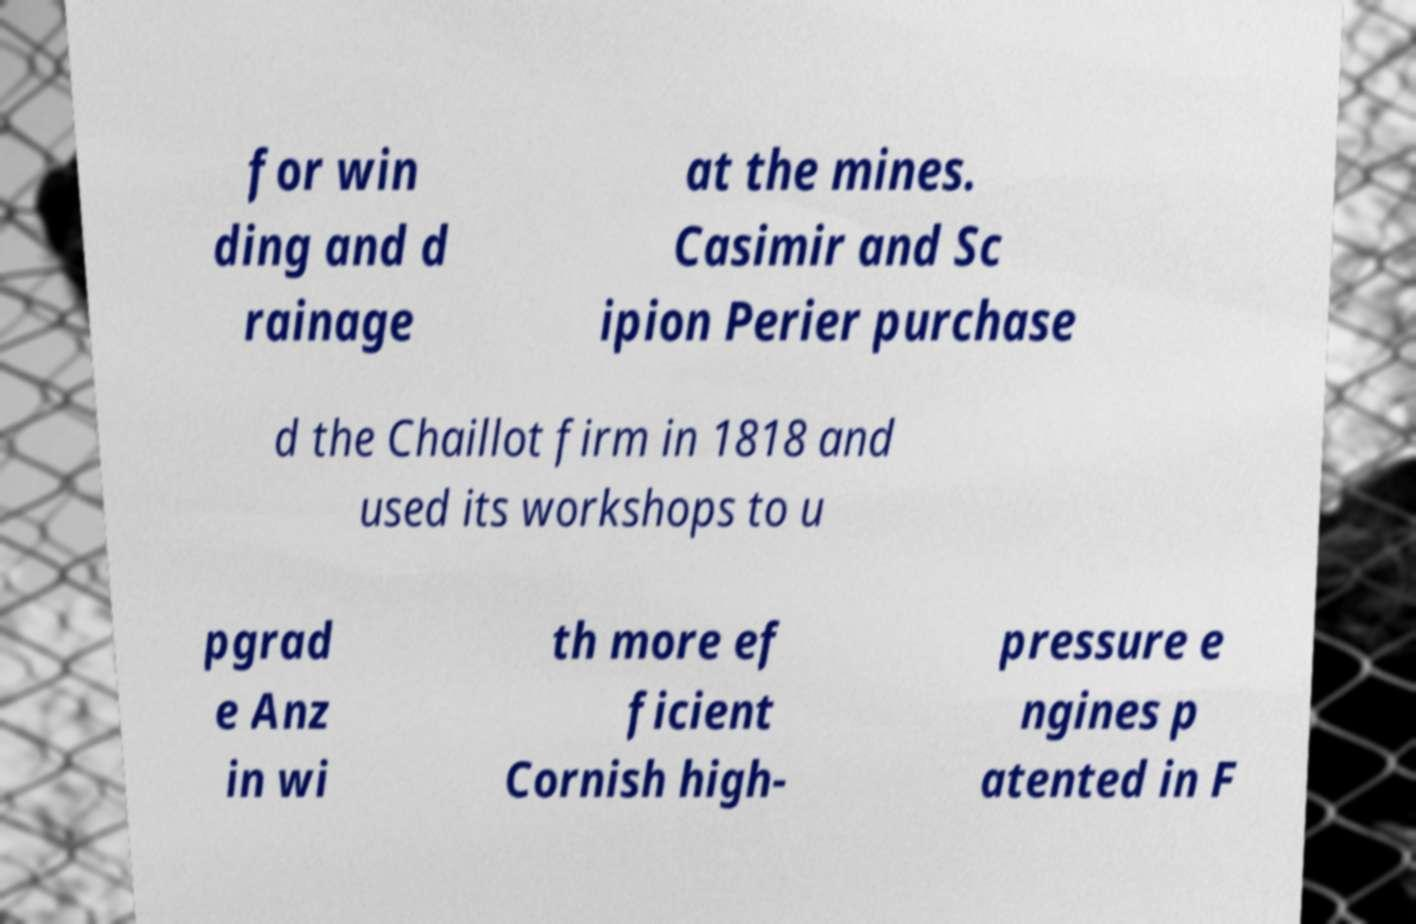There's text embedded in this image that I need extracted. Can you transcribe it verbatim? for win ding and d rainage at the mines. Casimir and Sc ipion Perier purchase d the Chaillot firm in 1818 and used its workshops to u pgrad e Anz in wi th more ef ficient Cornish high- pressure e ngines p atented in F 